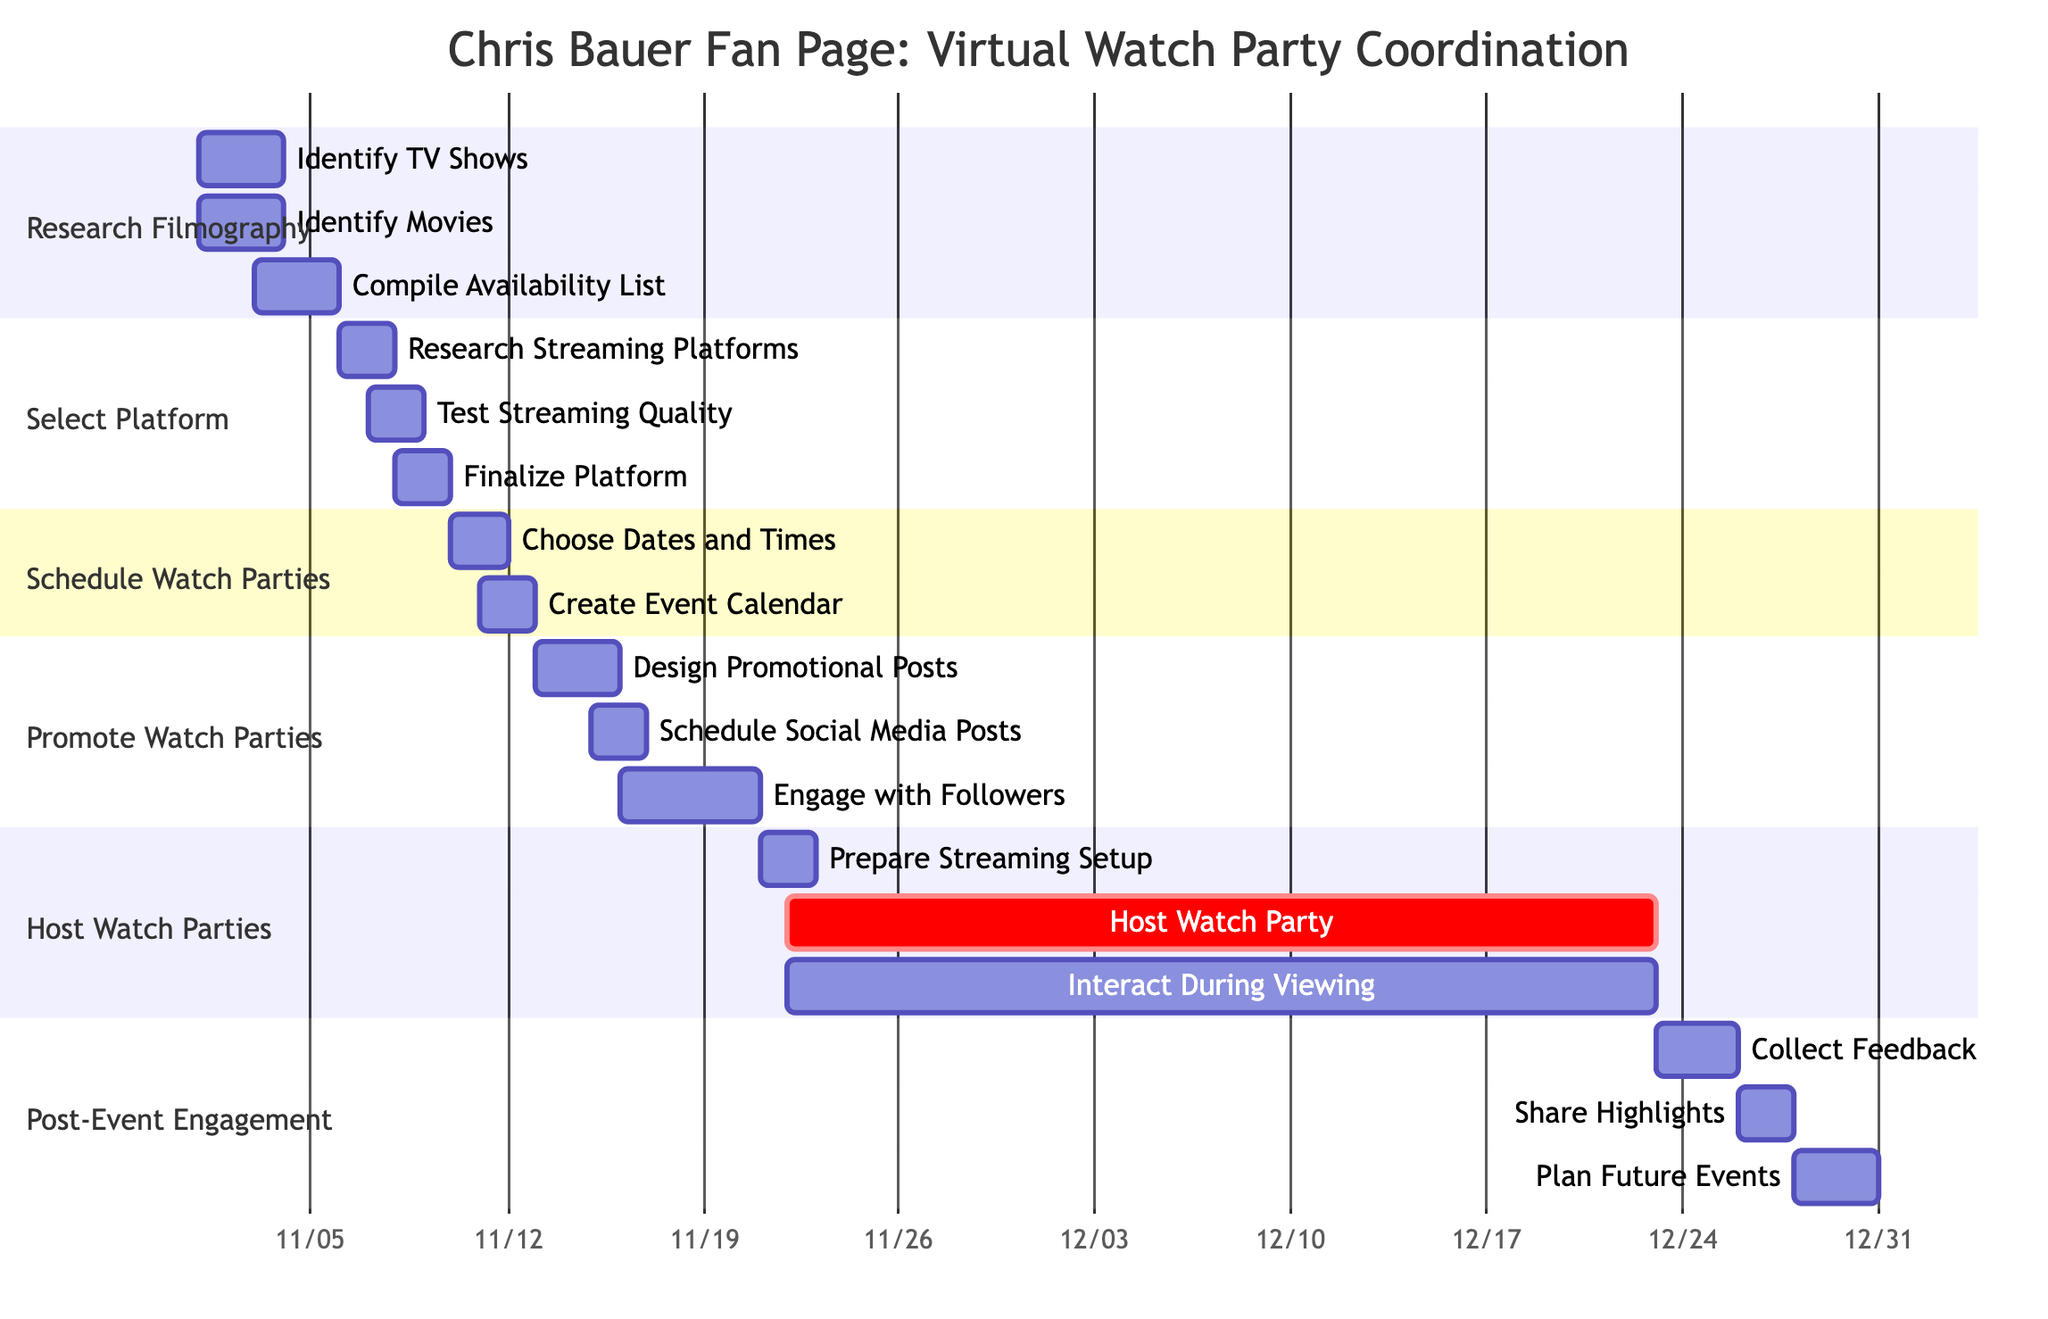What is the duration of the task "Host Watch Party"? The task "Host Watch Party" starts on November 22, 2023, and ends on December 22, 2023. This means it spans a total of 31 days.
Answer: 31 days How many subtasks are there in the "Promote Watch Parties" section? The "Promote Watch Parties" section has three subtasks: "Design Promotional Posts," "Schedule Social Media Posts," and "Engage with Followers." Counting these gives us a total of three subtasks.
Answer: 3 What is the start date of the "Collect Feedback" task? The "Collect Feedback" task starts on December 23, 2023, which is directly indicated in the diagram under the "Post-Event Engagement" section.
Answer: December 23, 2023 Which task overlaps with the "Plan Future Events"? The "Plan Future Events" task begins on December 28, 2023, and since "Share Highlights" ends on December 27 and "Collect Feedback" ends on December 25, there are no other tasks within the same time frame. Therefore, "Plan Future Events" does not have an overlapping task but directly follows the completion of "Share Highlights."
Answer: None In which section is "Research Streaming Platforms" located? The "Research Streaming Platforms" subtask is located within the "Select Platform" section of the Gantt chart. This can be identified by looking at the structuring of the diagram, where tasks are organized into distinct sections.
Answer: Select Platform What is the end date for the "Engage with Followers" task? The "Engage with Followers" task starts on November 16, 2023, and ends on November 20, 2023. Therefore, the end date is noted in the diagram.
Answer: November 20, 2023 